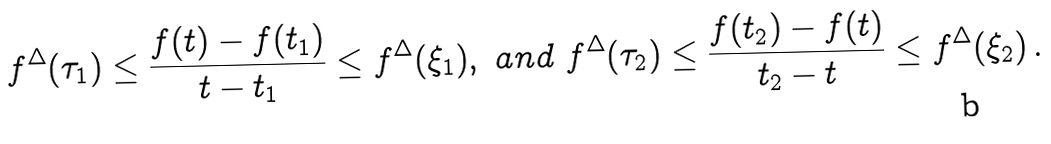Convert formula to latex. <formula><loc_0><loc_0><loc_500><loc_500>f ^ { \Delta } ( \tau _ { 1 } ) \leq \frac { f ( t ) - f ( t _ { 1 } ) } { t - t _ { 1 } } \leq f ^ { \Delta } ( \xi _ { 1 } ) , \ a n d \ f ^ { \Delta } ( \tau _ { 2 } ) \leq \frac { f ( t _ { 2 } ) - f ( t ) } { t _ { 2 } - t } \leq f ^ { \Delta } ( \xi _ { 2 } ) \, .</formula> 